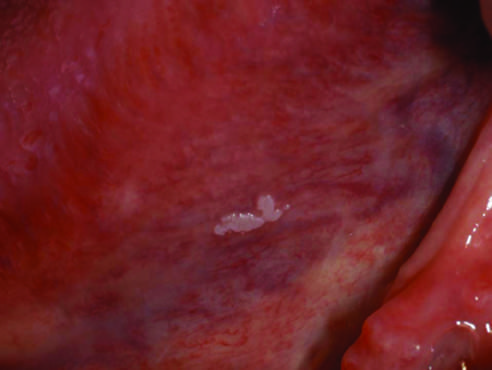s the lesion smooth with well-demarcated borders and minimal elevation in this example?
Answer the question using a single word or phrase. Yes 